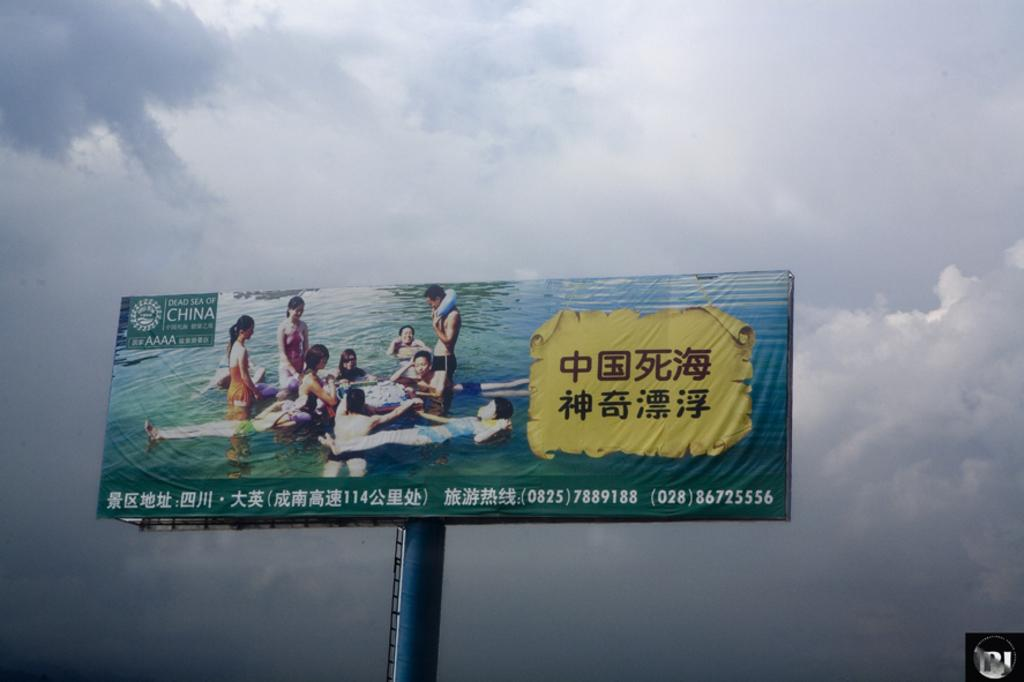<image>
Summarize the visual content of the image. A billboard from the Dead Sea of China showing  Asian Men and Women in a body of water. 